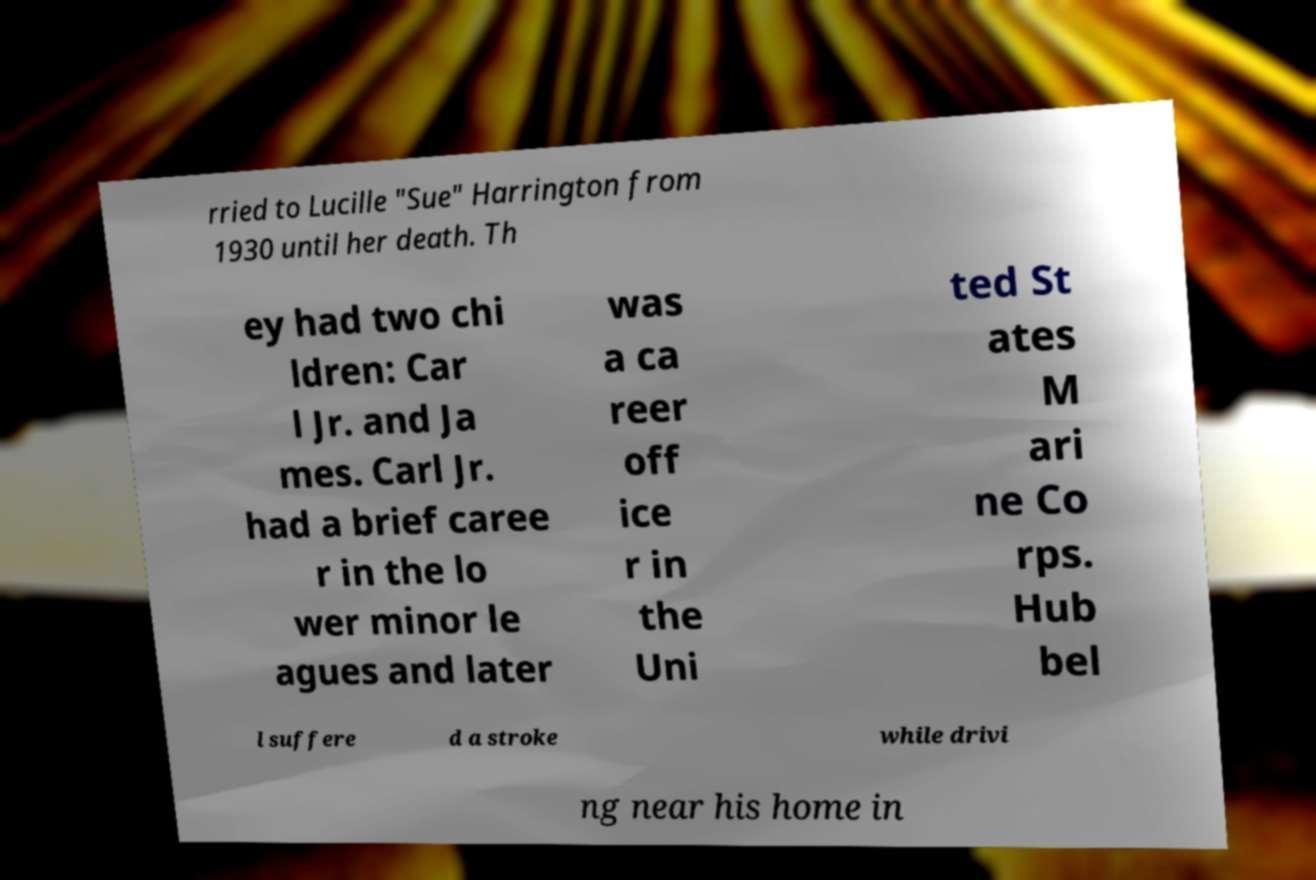Please identify and transcribe the text found in this image. rried to Lucille "Sue" Harrington from 1930 until her death. Th ey had two chi ldren: Car l Jr. and Ja mes. Carl Jr. had a brief caree r in the lo wer minor le agues and later was a ca reer off ice r in the Uni ted St ates M ari ne Co rps. Hub bel l suffere d a stroke while drivi ng near his home in 